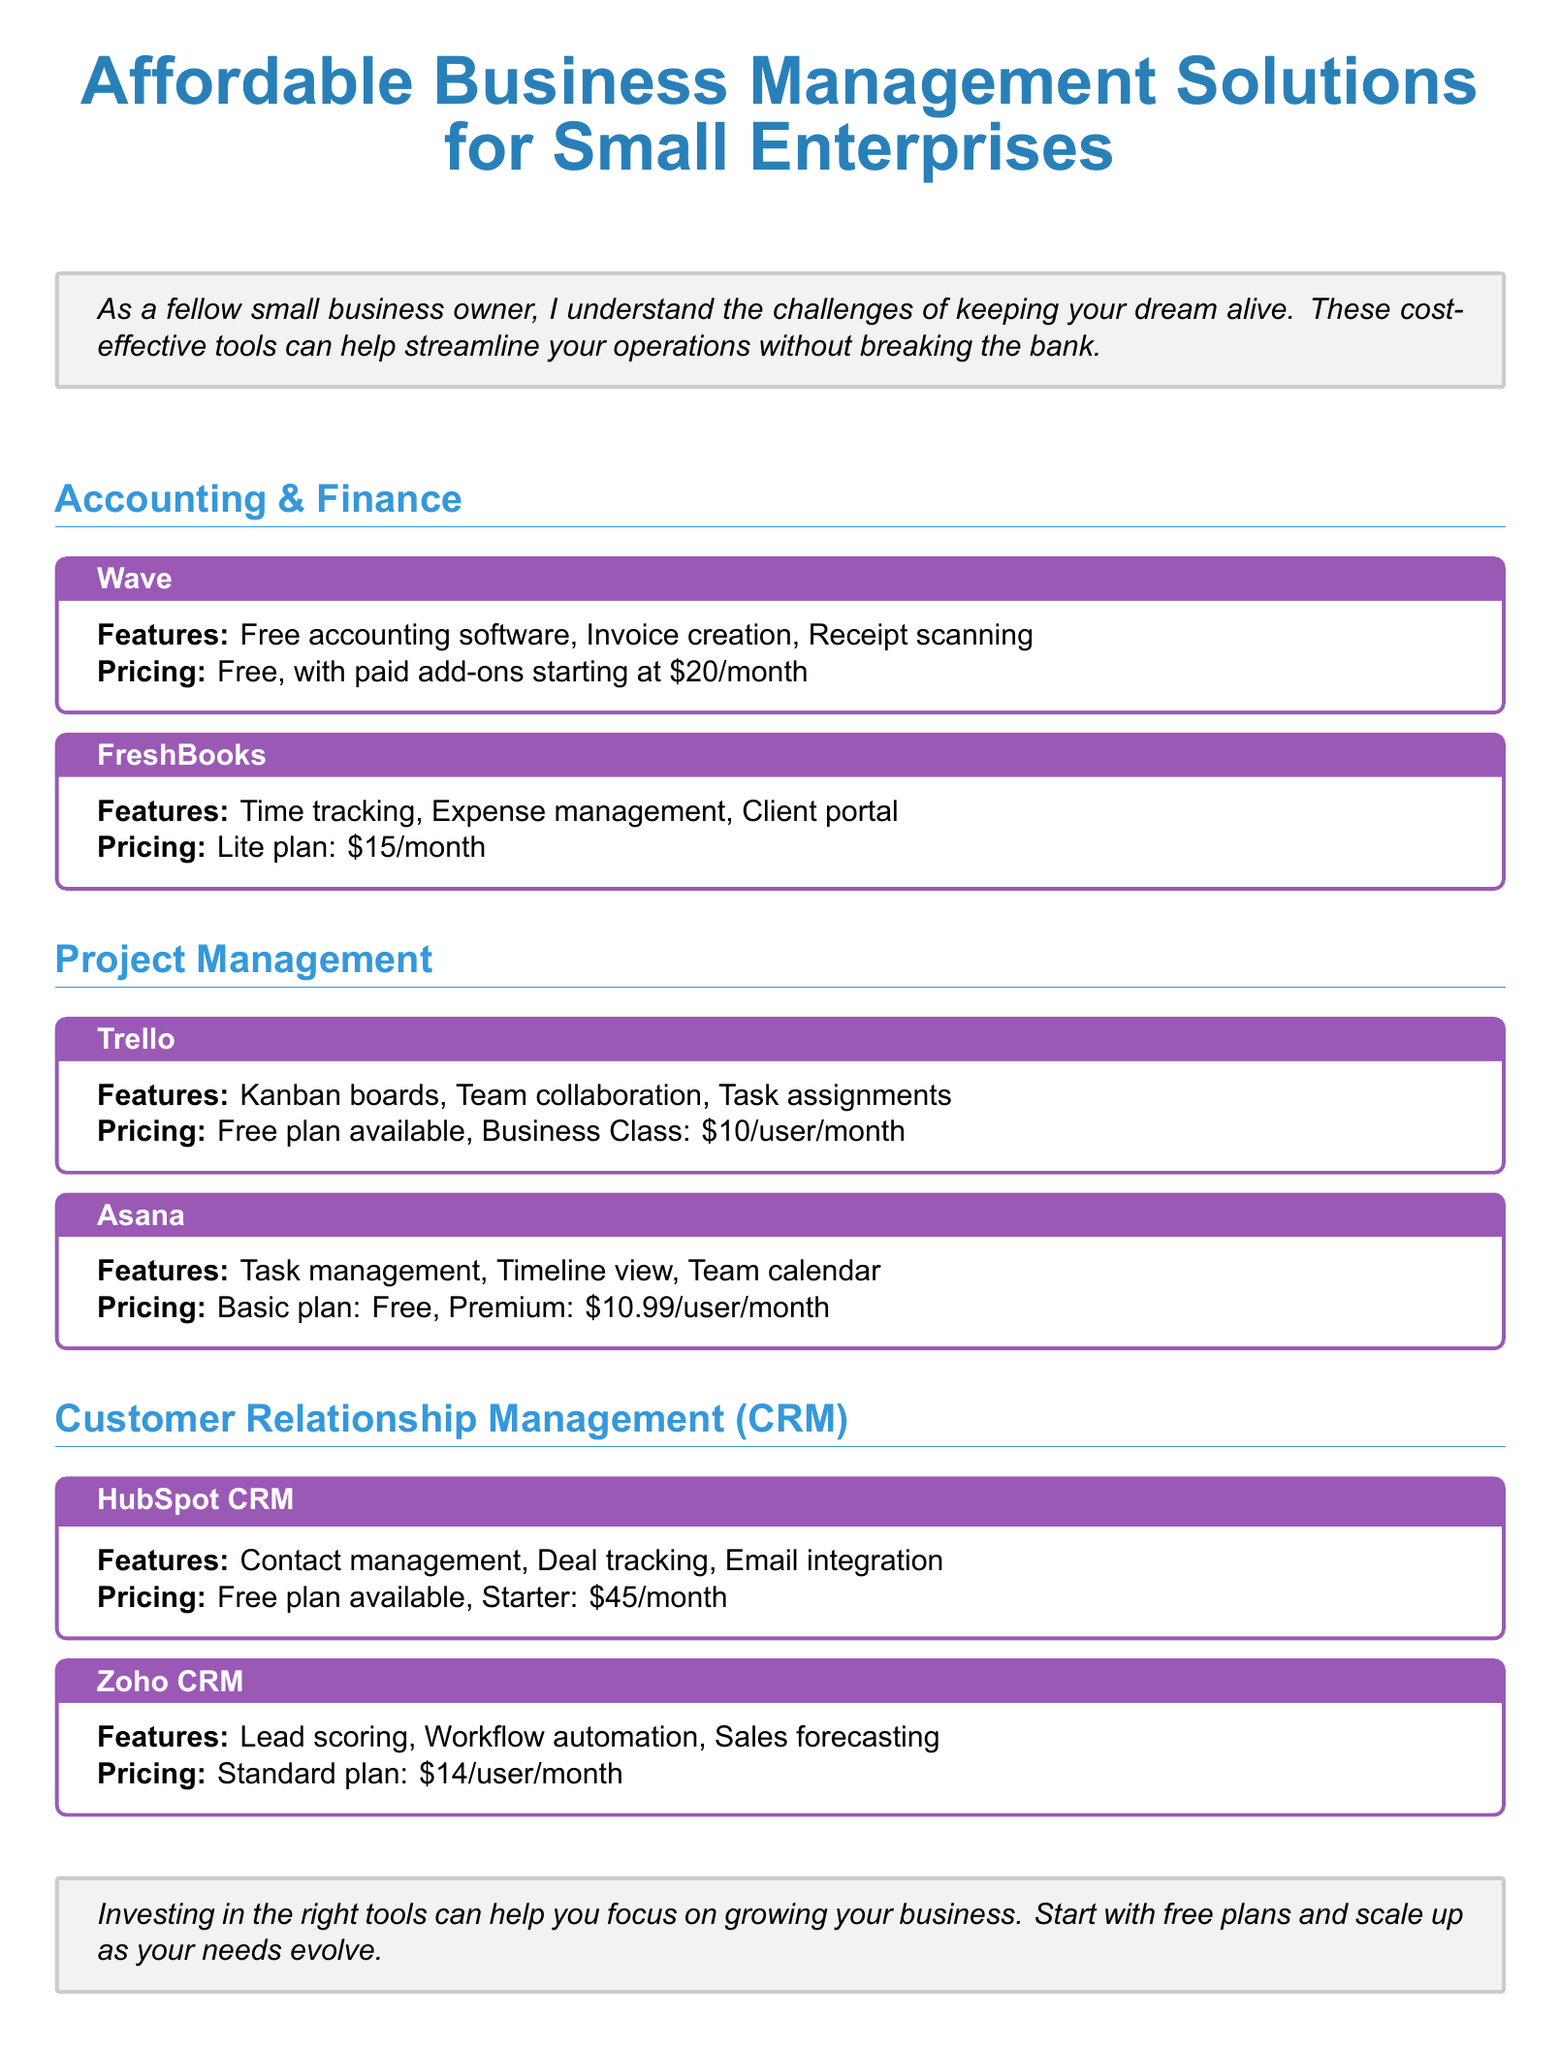what is the title of the document? The title of the document is prominently displayed at the top and is "Affordable Business Management Solutions for Small Enterprises."
Answer: Affordable Business Management Solutions for Small Enterprises which tool offers a free accounting software? The document lists several tools, and Wave is specifically mentioned as providing free accounting software.
Answer: Wave what is the pricing for FreshBooks Lite plan? FreshBooks is described in terms of its pricing for the Lite plan, which is $15 per month.
Answer: $15/month what feature does Trello provide for team collaboration? Trello is mentioned to provide a specific feature that facilitates collaboration among team members: Kanban boards.
Answer: Kanban boards how much does the Standard plan of Zoho CRM cost? The document specifies the pricing for Zoho CRM's Standard plan, which is $14 per user per month.
Answer: $14/user/month what is the pricing for HubSpot CRM Starter plan? The document indicates that the Starter plan for HubSpot CRM is priced at $45 per month.
Answer: $45/month which project management tool offers a free plan? Among the listed tools, Asana is specified to provide a Basic plan that is free for users.
Answer: Asana what are two features of the FreshBooks software? FreshBooks is described with several features, specifically time tracking and expense management.
Answer: Time tracking, Expense management 